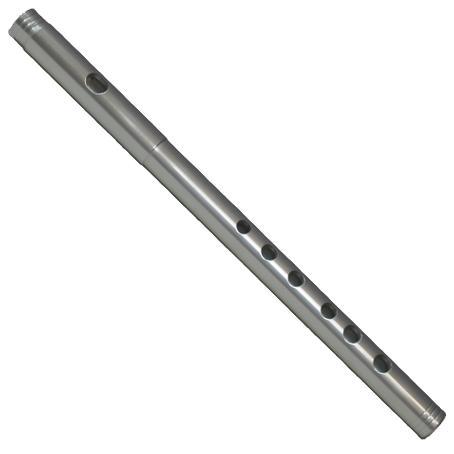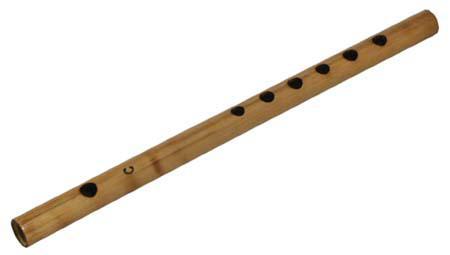The first image is the image on the left, the second image is the image on the right. Examine the images to the left and right. Is the description "The left and right image contains the same number of flutes." accurate? Answer yes or no. Yes. The first image is the image on the left, the second image is the image on the right. Considering the images on both sides, is "The left image contains a single flute displayed at an angle, and the right image includes one flute displayed at an angle opposite that of the flute on the left." valid? Answer yes or no. Yes. 